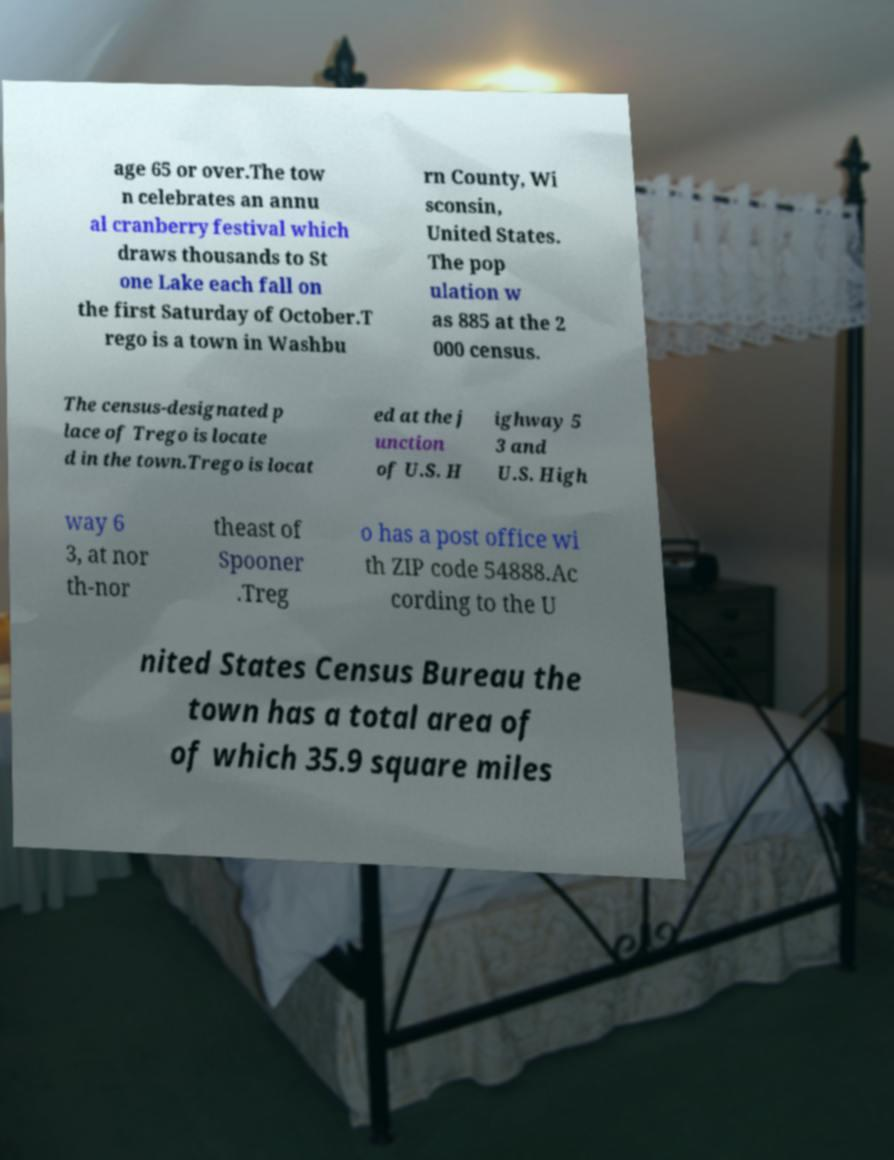Please identify and transcribe the text found in this image. age 65 or over.The tow n celebrates an annu al cranberry festival which draws thousands to St one Lake each fall on the first Saturday of October.T rego is a town in Washbu rn County, Wi sconsin, United States. The pop ulation w as 885 at the 2 000 census. The census-designated p lace of Trego is locate d in the town.Trego is locat ed at the j unction of U.S. H ighway 5 3 and U.S. High way 6 3, at nor th-nor theast of Spooner .Treg o has a post office wi th ZIP code 54888.Ac cording to the U nited States Census Bureau the town has a total area of of which 35.9 square miles 